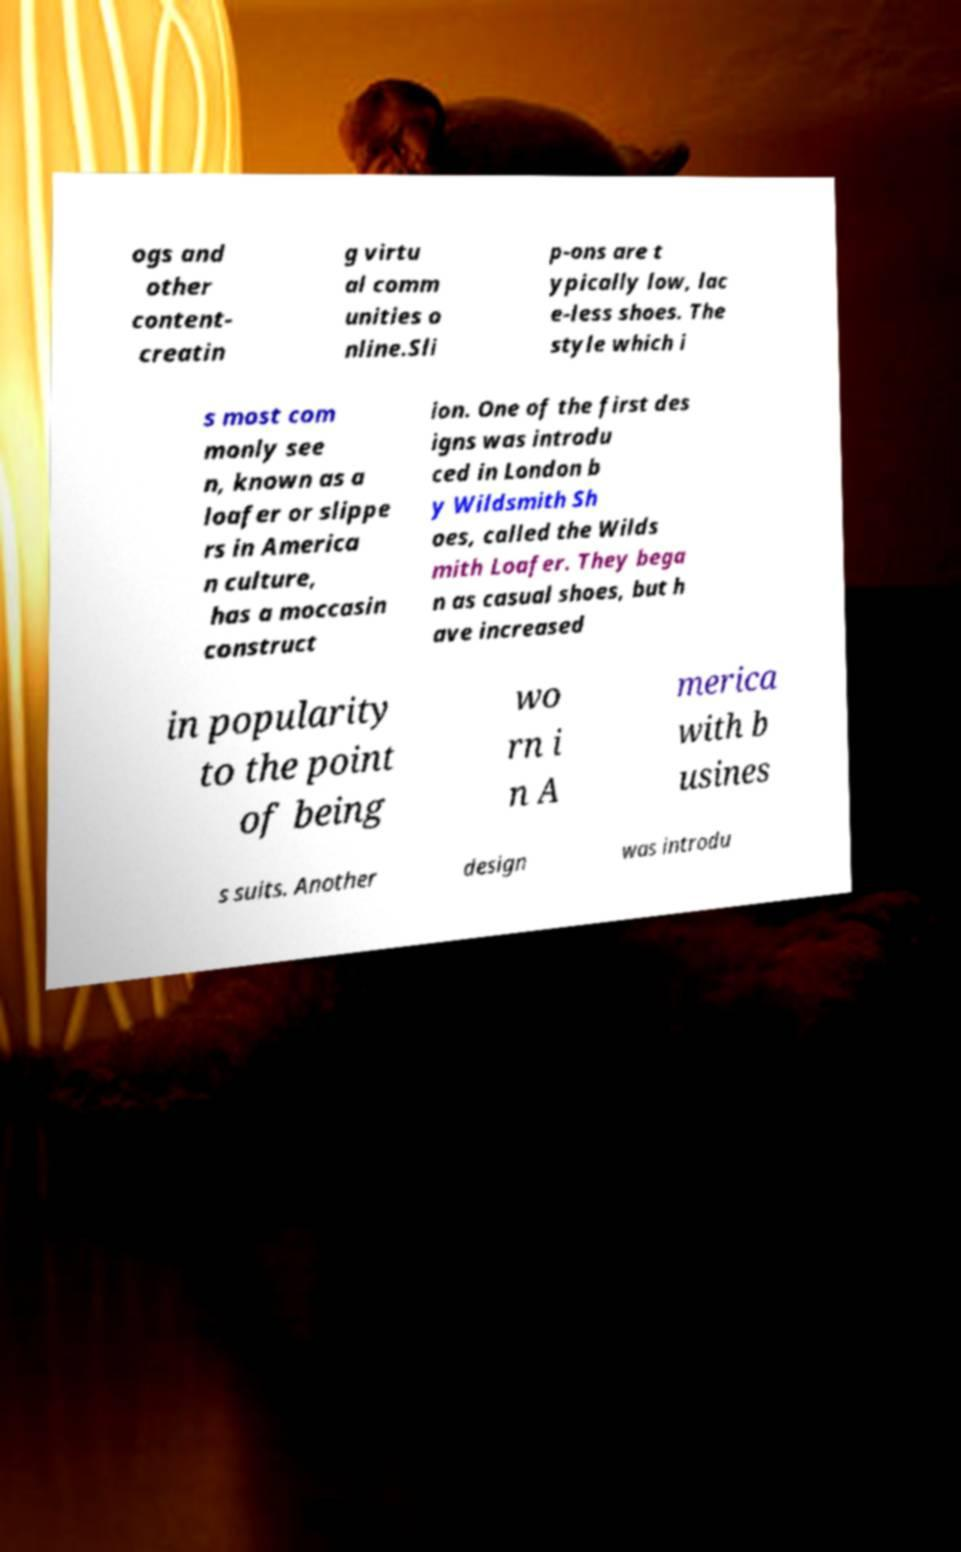Please identify and transcribe the text found in this image. ogs and other content- creatin g virtu al comm unities o nline.Sli p-ons are t ypically low, lac e-less shoes. The style which i s most com monly see n, known as a loafer or slippe rs in America n culture, has a moccasin construct ion. One of the first des igns was introdu ced in London b y Wildsmith Sh oes, called the Wilds mith Loafer. They bega n as casual shoes, but h ave increased in popularity to the point of being wo rn i n A merica with b usines s suits. Another design was introdu 